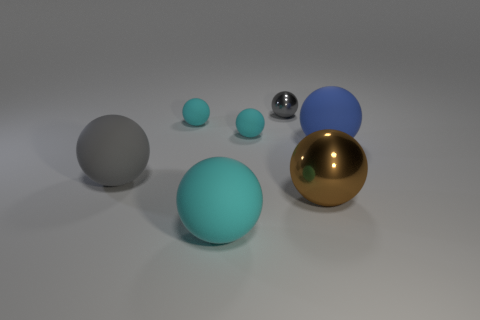Does the brown metallic ball have the same size as the blue matte thing?
Offer a very short reply. Yes. How many other things are the same shape as the big blue object?
Your response must be concise. 6. The blue object right of the big cyan matte object has what shape?
Your response must be concise. Sphere. There is a small gray metal thing behind the big brown ball; is it the same shape as the tiny cyan rubber thing that is to the right of the big cyan sphere?
Keep it short and to the point. Yes. Is the number of large rubber balls on the right side of the gray metallic sphere the same as the number of large blue spheres?
Offer a terse response. Yes. There is a small gray thing that is the same shape as the blue rubber thing; what material is it?
Your answer should be compact. Metal. There is a big metallic object that is left of the blue matte thing to the right of the big gray matte ball; what is its shape?
Offer a terse response. Sphere. Are the cyan ball that is in front of the big metal ball and the large blue thing made of the same material?
Provide a succinct answer. Yes. Is the number of gray metallic spheres on the right side of the large blue rubber object the same as the number of shiny balls behind the large brown metal object?
Your response must be concise. No. There is a sphere that is right of the brown metal thing; what number of spheres are in front of it?
Offer a very short reply. 3. 